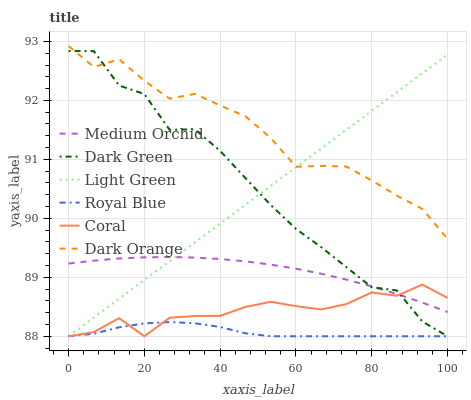Does Royal Blue have the minimum area under the curve?
Answer yes or no. Yes. Does Dark Orange have the maximum area under the curve?
Answer yes or no. Yes. Does Coral have the minimum area under the curve?
Answer yes or no. No. Does Coral have the maximum area under the curve?
Answer yes or no. No. Is Light Green the smoothest?
Answer yes or no. Yes. Is Dark Green the roughest?
Answer yes or no. Yes. Is Coral the smoothest?
Answer yes or no. No. Is Coral the roughest?
Answer yes or no. No. Does Coral have the lowest value?
Answer yes or no. Yes. Does Medium Orchid have the lowest value?
Answer yes or no. No. Does Dark Orange have the highest value?
Answer yes or no. Yes. Does Coral have the highest value?
Answer yes or no. No. Is Coral less than Dark Orange?
Answer yes or no. Yes. Is Medium Orchid greater than Royal Blue?
Answer yes or no. Yes. Does Dark Green intersect Dark Orange?
Answer yes or no. Yes. Is Dark Green less than Dark Orange?
Answer yes or no. No. Is Dark Green greater than Dark Orange?
Answer yes or no. No. Does Coral intersect Dark Orange?
Answer yes or no. No. 